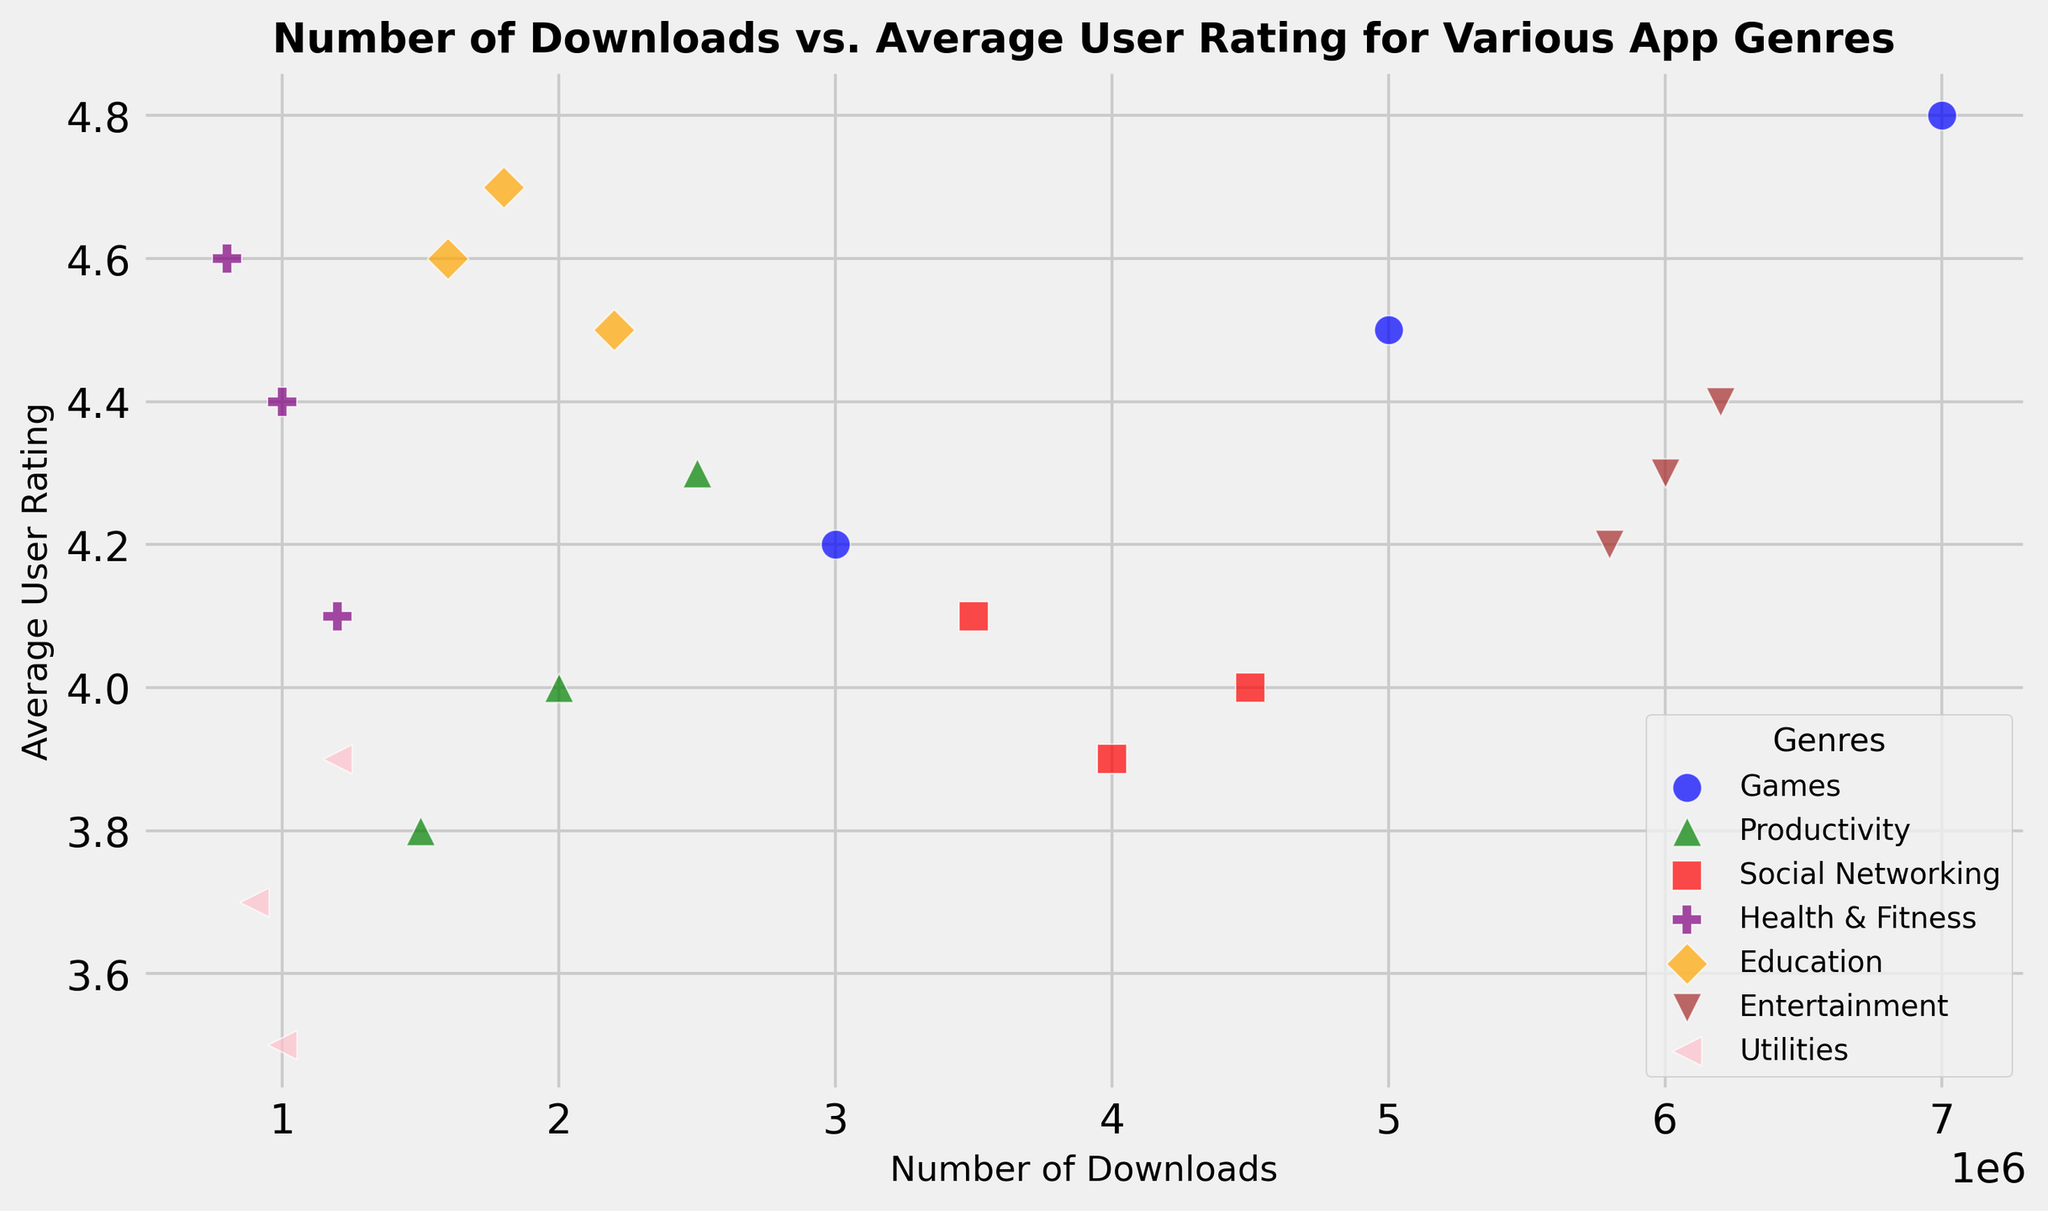What's the average user rating for the "Health & Fitness" genre? First, locate all the points for "Health & Fitness" on the scatter plot. There are 3 data points with ratings 4.4, 4.6, and 4.1. Add these ratings (4.4 + 4.6 + 4.1 = 13.1) and divide by the number of points (3) to find the average.
Answer: 4.37 Which genre has the highest number of downloads? Identify the data points with the highest number of downloads by looking at the x-axis. The "Games" genre has a point with 7,000,000 downloads, which is higher than all others.
Answer: Games What is the range of average user ratings observed for the "Education" genre? Find all the "Education" points' ratings. They are 4.7, 4.6, and 4.5. The range is calculated as the difference between the highest (4.7) and the lowest (4.5) values. (4.7 - 4.5 = 0.2)
Answer: 0.2 Which genre has the widest spread in both the number of downloads and average user ratings? Compare the spread of points for each genre. "Games" are spread widely both horizontally (downloads 3,000,000 to 7,000,000) and vertically (ratings 4.2 to 4.8). Other genres are closer together.
Answer: Games Are there any genres where all points have average user ratings above 4.0? Check each genre's points. "Health & Fitness" (4.4, 4.6, 4.1), "Education" (4.7, 4.6, 4.5), and "Entertainment" (4.3, 4.2, 4.4) all have ratings above 4.0.
Answer: Yes Which genres have data points with average user ratings below 4.0? Identify and note down the genres with any points below the rating of 4.0. "Productivity" (3.8), "Social Networking" (3.9), and "Utilities" (3.5, 3.7) have ratings below 4.0.
Answer: Productivity, Social Networking, Utilities How does the "Productivity" genre compare in terms of average user rating to "Utilities"? Find the average user ratings for both genres. "Productivity" has points with 4.0, 3.8, and 4.3. "Utilities" has 3.5, 3.9, and 3.7. The average for "Productivity" is (4.0 + 3.8 + 4.3) / 3 = 4.03 and for "Utilities" (3.5 + 3.9 + 3.7) / 3 = 3.7.
Answer: Productivity has higher ratings Which genre has the lowest average user rating at its highest number of downloads? Check each genre's highest downloads point and its associated rating. "Utilities" with 1,200,000 downloads has an average rating of 3.9. This is the lowest compared to other genres' highest download points.
Answer: Utilities 